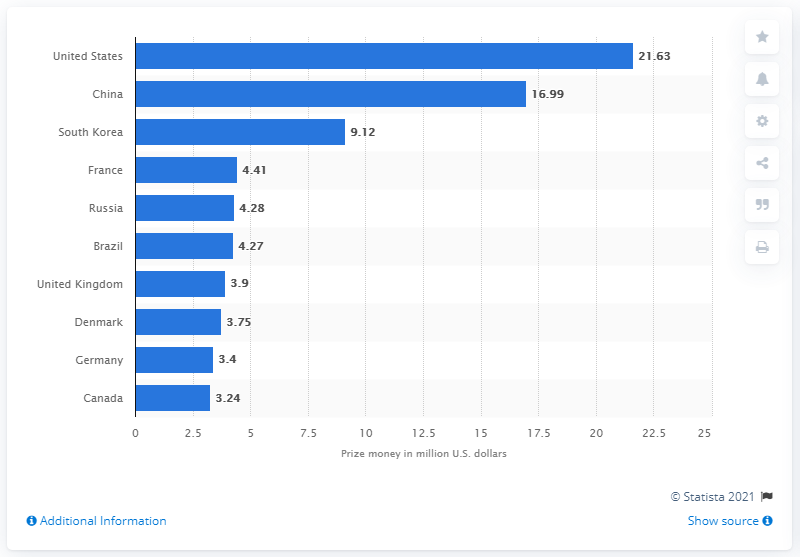List a handful of essential elements in this visual. The United States won $21.63 million in eSports competitions in 2020. 